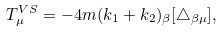<formula> <loc_0><loc_0><loc_500><loc_500>T _ { \mu } ^ { V S } = - 4 m ( k _ { 1 } + k _ { 2 } ) _ { \beta } [ \triangle _ { \beta \mu } ] ,</formula> 